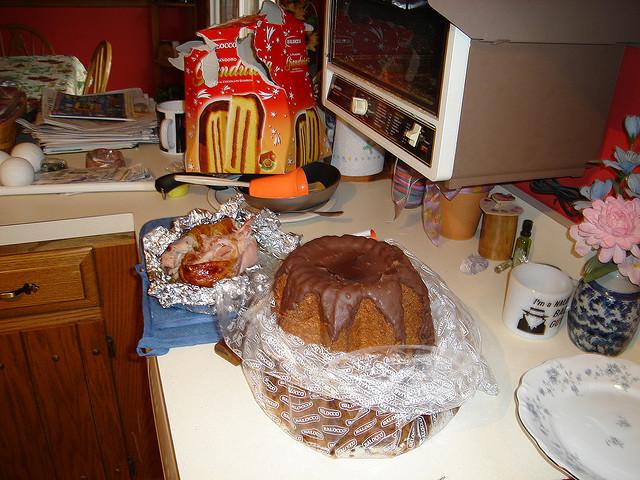What is the name of this shop?
Quick response, please. None. Is the cake homemade?
Quick response, please. No. Does that box of tofurkey have meat in it??
Answer briefly. No. What is in the clear bowl to the very right?
Answer briefly. Cake. How many eggs are on the counter?
Write a very short answer. 3. How many towels are in this photo?
Answer briefly. 1. Is the cake whole?
Concise answer only. Yes. How many chairs are visible?
Be succinct. 0. 